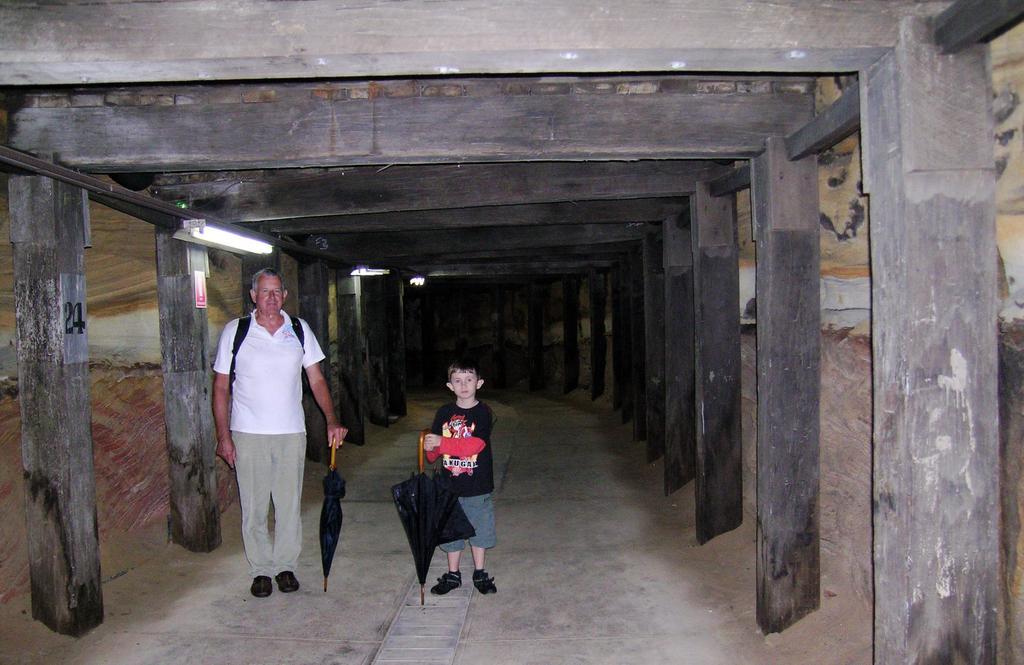Can you describe this image briefly? In this image we can see a person who is standing and holding an umbrella. And besides him a boy standing with the umbrella in his hands. And both wear shoes. And on the background there is a wall. and this is the light. Here we can see this floor. 